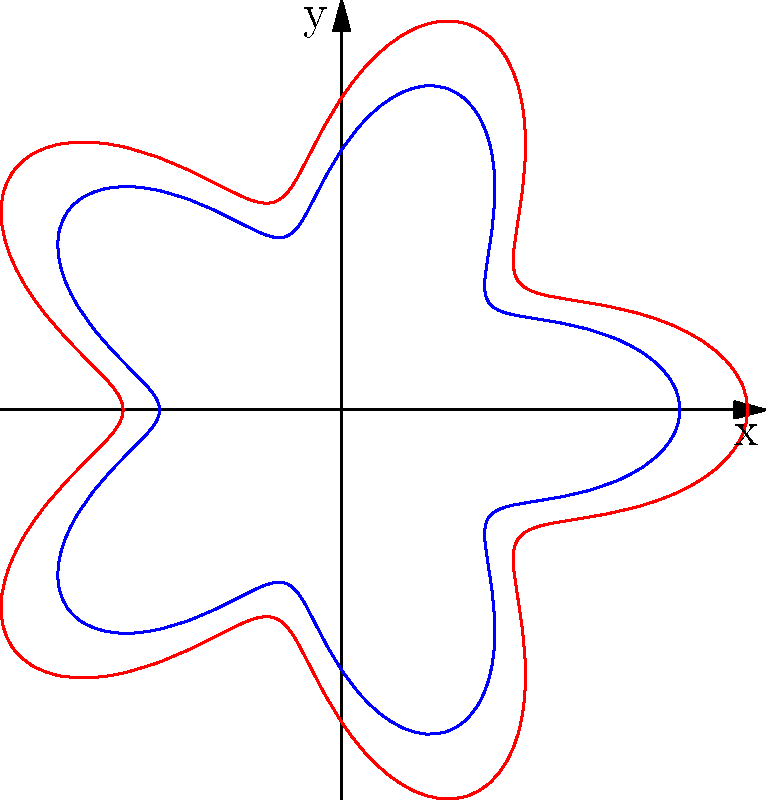In creating an intricate border pattern for a Vietnamese-inspired fabric design, you use the polar equation $r = 1 + 0.3\cos(5\theta)$ to generate a base pattern. To create a layered effect, you want to scale this pattern outward by 20%. What is the new polar equation for the scaled pattern? To solve this problem, let's follow these steps:

1) The original polar equation is:
   $r = 1 + 0.3\cos(5\theta)$

2) To scale a polar equation by a factor $k$, we multiply the entire right-hand side by $k$:
   $r_{new} = k(1 + 0.3\cos(5\theta))$

3) In this case, we want to scale by 20%, which means multiplying by 1.2:
   $r_{new} = 1.2(1 + 0.3\cos(5\theta))$

4) Let's distribute the 1.2:
   $r_{new} = 1.2 + 1.2(0.3\cos(5\theta))$

5) Simplify:
   $r_{new} = 1.2 + 0.36\cos(5\theta)$

This new equation will create a pattern that is 20% larger than the original, maintaining the same shape but expanding it outward, which could create an interesting layered effect in the fabric design.
Answer: $r = 1.2 + 0.36\cos(5\theta)$ 